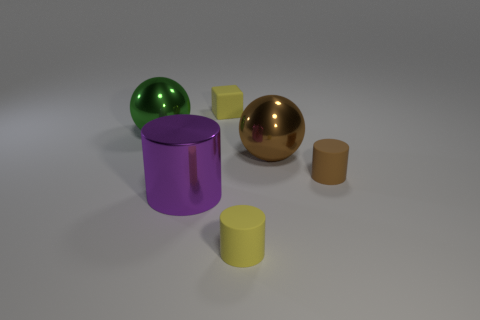Subtract all small cylinders. How many cylinders are left? 1 Add 3 rubber objects. How many objects exist? 9 Subtract all green spheres. How many spheres are left? 1 Subtract 1 blocks. How many blocks are left? 0 Add 5 big brown spheres. How many big brown spheres are left? 6 Add 6 green shiny cubes. How many green shiny cubes exist? 6 Subtract 0 gray spheres. How many objects are left? 6 Subtract all spheres. How many objects are left? 4 Subtract all brown blocks. Subtract all gray spheres. How many blocks are left? 1 Subtract all large blue spheres. Subtract all brown shiny objects. How many objects are left? 5 